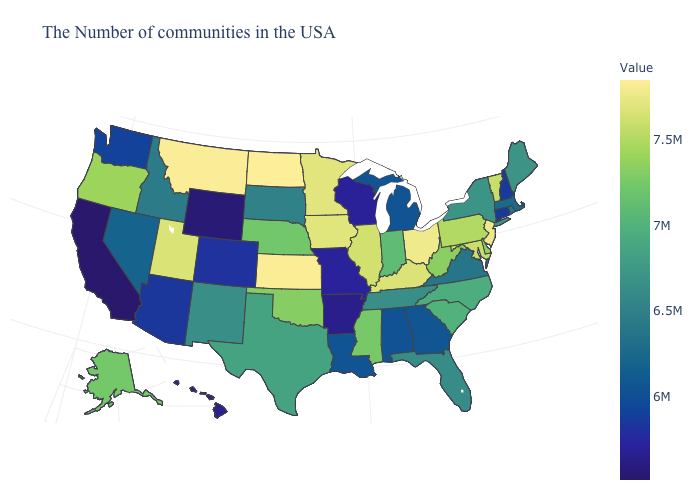Is the legend a continuous bar?
Give a very brief answer. Yes. Does North Dakota have the highest value in the USA?
Concise answer only. Yes. Does Arkansas have the lowest value in the South?
Write a very short answer. Yes. Does Illinois have the lowest value in the USA?
Write a very short answer. No. 